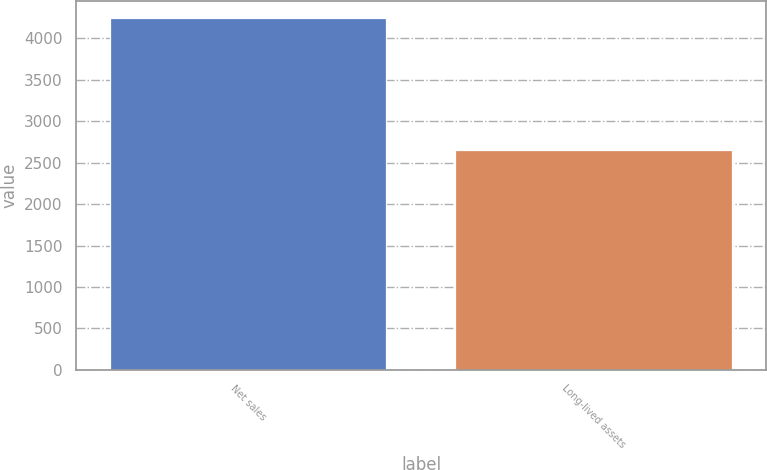Convert chart. <chart><loc_0><loc_0><loc_500><loc_500><bar_chart><fcel>Net sales<fcel>Long-lived assets<nl><fcel>4243.2<fcel>2655.7<nl></chart> 